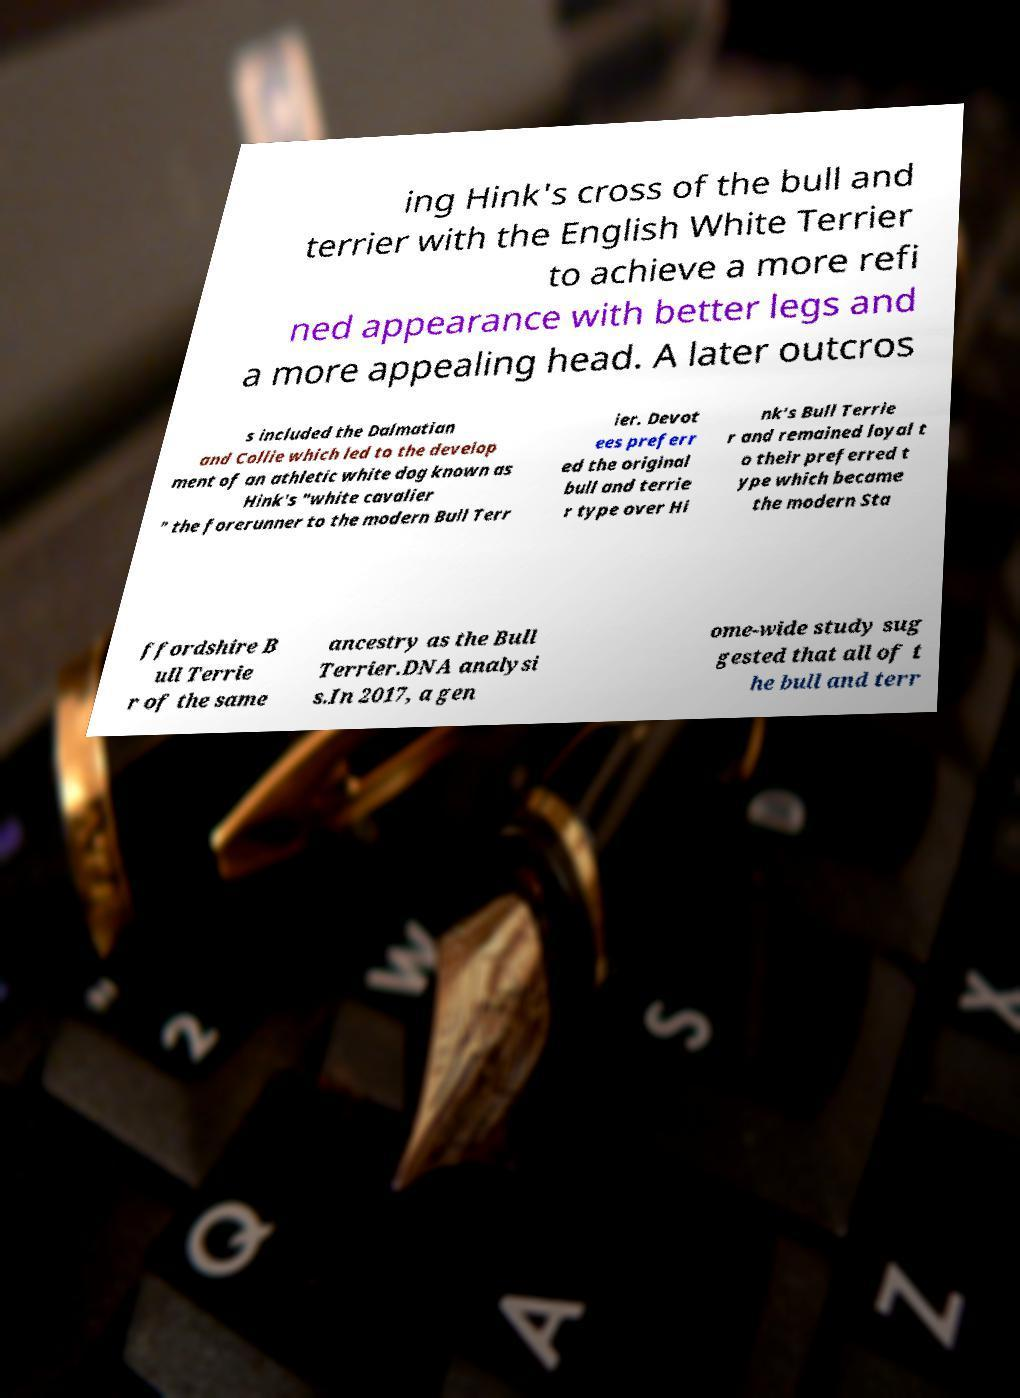Can you read and provide the text displayed in the image?This photo seems to have some interesting text. Can you extract and type it out for me? ing Hink's cross of the bull and terrier with the English White Terrier to achieve a more refi ned appearance with better legs and a more appealing head. A later outcros s included the Dalmatian and Collie which led to the develop ment of an athletic white dog known as Hink's "white cavalier " the forerunner to the modern Bull Terr ier. Devot ees preferr ed the original bull and terrie r type over Hi nk's Bull Terrie r and remained loyal t o their preferred t ype which became the modern Sta ffordshire B ull Terrie r of the same ancestry as the Bull Terrier.DNA analysi s.In 2017, a gen ome-wide study sug gested that all of t he bull and terr 